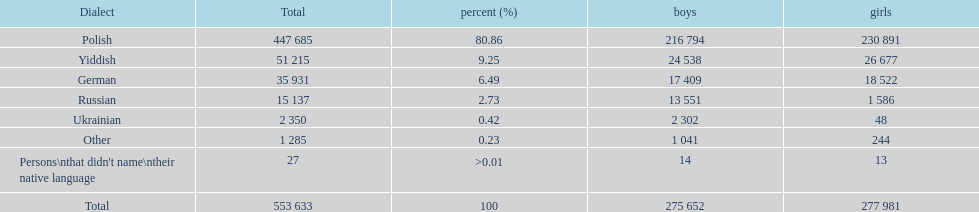How many male and female german speakers are there? 35931. 